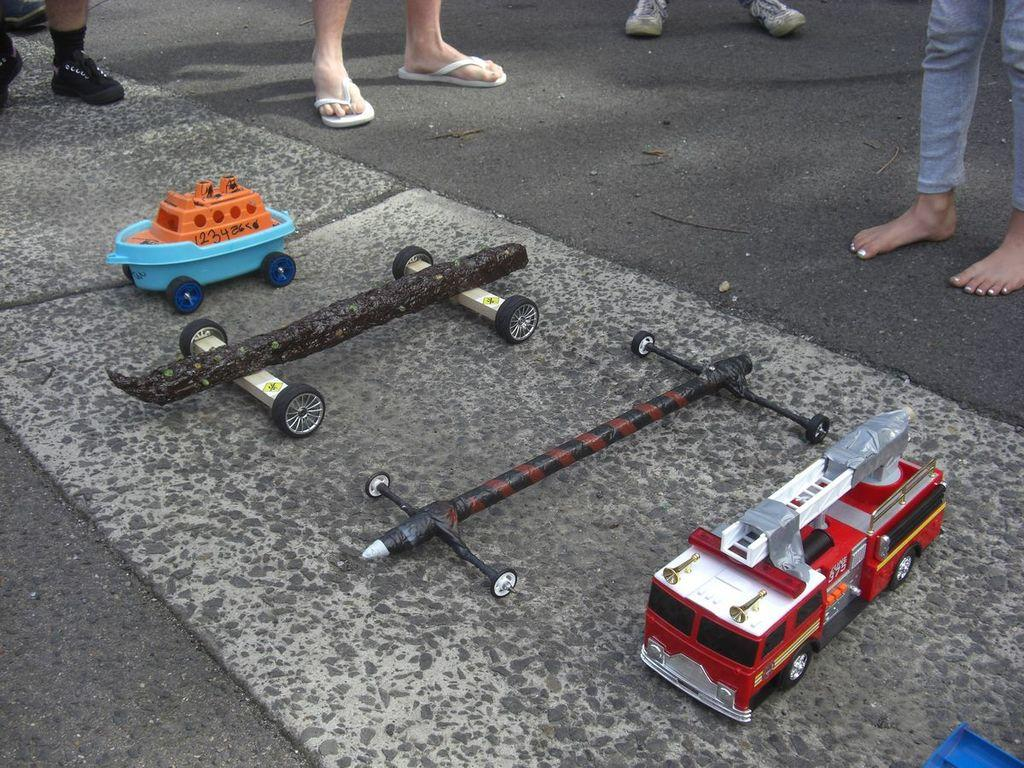What can be seen in the image that belongs to people? There are legs of people visible in the image. What else is present in the image besides people's legs? There are toys in the image. What type of cap can be seen on the toys in the image? There are no caps present on the toys in the image. How many times do the toys kick the ball in the image? There is no ball or kicking action present in the image. 